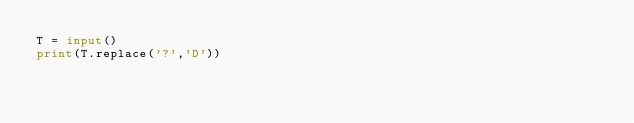Convert code to text. <code><loc_0><loc_0><loc_500><loc_500><_Python_>T = input()
print(T.replace('?','D'))
</code> 